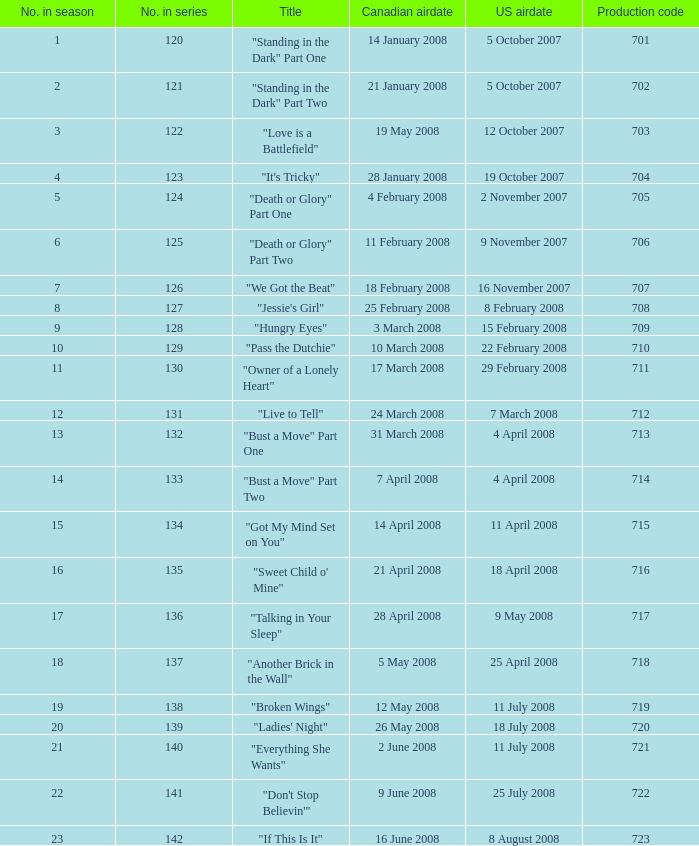The canadian airdate of 11 february 2008 applied to what series number? 1.0. 